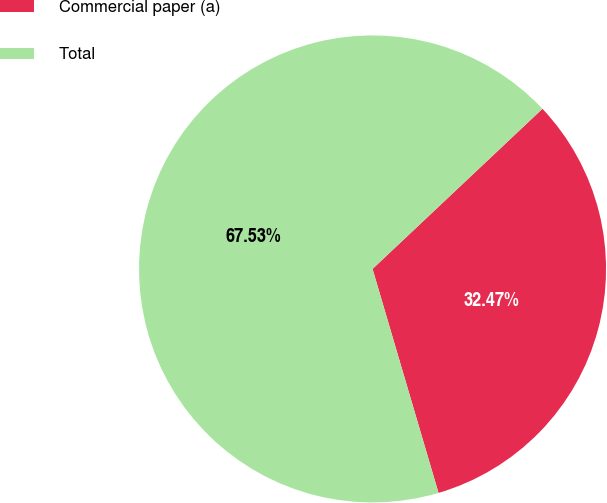Convert chart. <chart><loc_0><loc_0><loc_500><loc_500><pie_chart><fcel>Commercial paper (a)<fcel>Total<nl><fcel>32.47%<fcel>67.53%<nl></chart> 